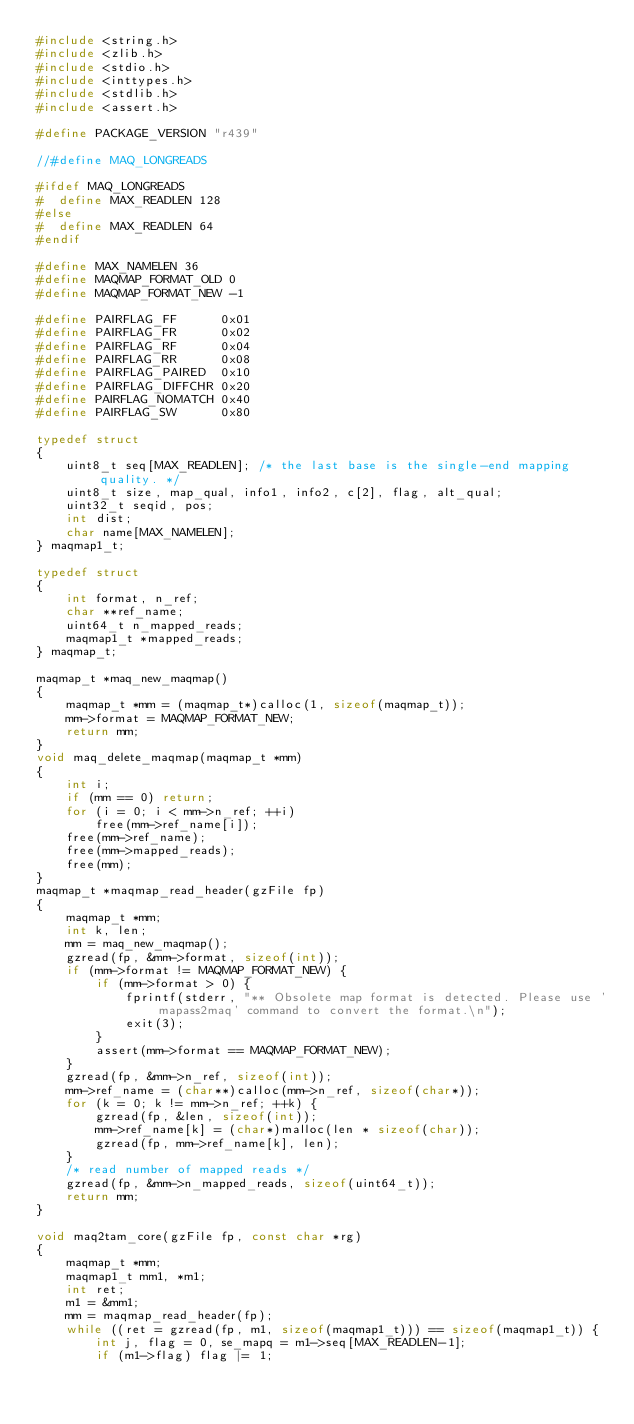<code> <loc_0><loc_0><loc_500><loc_500><_C_>#include <string.h>
#include <zlib.h>
#include <stdio.h>
#include <inttypes.h>
#include <stdlib.h>
#include <assert.h>

#define PACKAGE_VERSION "r439"

//#define MAQ_LONGREADS

#ifdef MAQ_LONGREADS
#  define MAX_READLEN 128
#else
#  define MAX_READLEN 64
#endif

#define MAX_NAMELEN 36
#define MAQMAP_FORMAT_OLD 0
#define MAQMAP_FORMAT_NEW -1

#define PAIRFLAG_FF      0x01
#define PAIRFLAG_FR      0x02
#define PAIRFLAG_RF      0x04
#define PAIRFLAG_RR      0x08
#define PAIRFLAG_PAIRED  0x10
#define PAIRFLAG_DIFFCHR 0x20
#define PAIRFLAG_NOMATCH 0x40
#define PAIRFLAG_SW      0x80

typedef struct
{
	uint8_t seq[MAX_READLEN]; /* the last base is the single-end mapping quality. */
	uint8_t size, map_qual, info1, info2, c[2], flag, alt_qual;
	uint32_t seqid, pos;
	int dist;
	char name[MAX_NAMELEN];
} maqmap1_t;

typedef struct
{
	int format, n_ref;
	char **ref_name;
	uint64_t n_mapped_reads;
	maqmap1_t *mapped_reads;
} maqmap_t;

maqmap_t *maq_new_maqmap()
{
	maqmap_t *mm = (maqmap_t*)calloc(1, sizeof(maqmap_t));
	mm->format = MAQMAP_FORMAT_NEW;
	return mm;
}
void maq_delete_maqmap(maqmap_t *mm)
{
	int i;
	if (mm == 0) return;
	for (i = 0; i < mm->n_ref; ++i)
		free(mm->ref_name[i]);
	free(mm->ref_name);
	free(mm->mapped_reads);
	free(mm);
}
maqmap_t *maqmap_read_header(gzFile fp)
{
	maqmap_t *mm;
	int k, len;
	mm = maq_new_maqmap();
	gzread(fp, &mm->format, sizeof(int));
	if (mm->format != MAQMAP_FORMAT_NEW) {
		if (mm->format > 0) {
			fprintf(stderr, "** Obsolete map format is detected. Please use 'mapass2maq' command to convert the format.\n");
			exit(3);
		}
		assert(mm->format == MAQMAP_FORMAT_NEW);
	}
	gzread(fp, &mm->n_ref, sizeof(int));
	mm->ref_name = (char**)calloc(mm->n_ref, sizeof(char*));
	for (k = 0; k != mm->n_ref; ++k) {
		gzread(fp, &len, sizeof(int));
		mm->ref_name[k] = (char*)malloc(len * sizeof(char));
		gzread(fp, mm->ref_name[k], len);
	}
	/* read number of mapped reads */
	gzread(fp, &mm->n_mapped_reads, sizeof(uint64_t));
	return mm;
}

void maq2tam_core(gzFile fp, const char *rg)
{
	maqmap_t *mm;
	maqmap1_t mm1, *m1;
	int ret;
	m1 = &mm1;
	mm = maqmap_read_header(fp);
	while ((ret = gzread(fp, m1, sizeof(maqmap1_t))) == sizeof(maqmap1_t)) {
		int j, flag = 0, se_mapq = m1->seq[MAX_READLEN-1];
		if (m1->flag) flag |= 1;</code> 